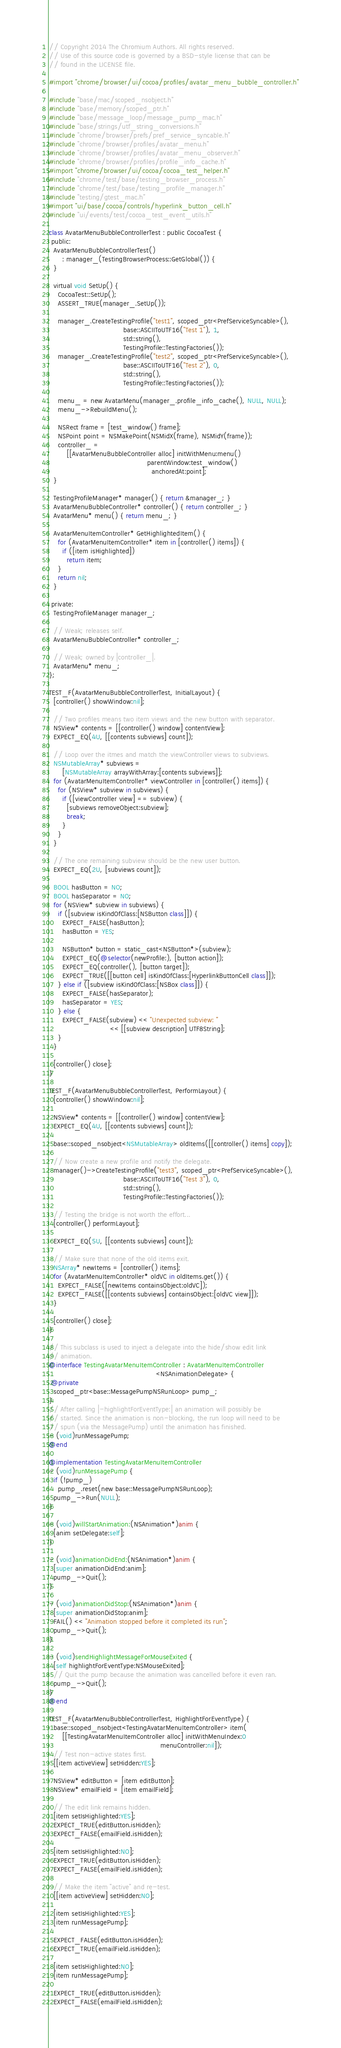<code> <loc_0><loc_0><loc_500><loc_500><_ObjectiveC_>// Copyright 2014 The Chromium Authors. All rights reserved.
// Use of this source code is governed by a BSD-style license that can be
// found in the LICENSE file.

#import "chrome/browser/ui/cocoa/profiles/avatar_menu_bubble_controller.h"

#include "base/mac/scoped_nsobject.h"
#include "base/memory/scoped_ptr.h"
#include "base/message_loop/message_pump_mac.h"
#include "base/strings/utf_string_conversions.h"
#include "chrome/browser/prefs/pref_service_syncable.h"
#include "chrome/browser/profiles/avatar_menu.h"
#include "chrome/browser/profiles/avatar_menu_observer.h"
#include "chrome/browser/profiles/profile_info_cache.h"
#import "chrome/browser/ui/cocoa/cocoa_test_helper.h"
#include "chrome/test/base/testing_browser_process.h"
#include "chrome/test/base/testing_profile_manager.h"
#include "testing/gtest_mac.h"
#import "ui/base/cocoa/controls/hyperlink_button_cell.h"
#include "ui/events/test/cocoa_test_event_utils.h"

class AvatarMenuBubbleControllerTest : public CocoaTest {
 public:
  AvatarMenuBubbleControllerTest()
      : manager_(TestingBrowserProcess::GetGlobal()) {
  }

  virtual void SetUp() {
    CocoaTest::SetUp();
    ASSERT_TRUE(manager_.SetUp());

    manager_.CreateTestingProfile("test1", scoped_ptr<PrefServiceSyncable>(),
                                  base::ASCIIToUTF16("Test 1"), 1,
                                  std::string(),
                                  TestingProfile::TestingFactories());
    manager_.CreateTestingProfile("test2", scoped_ptr<PrefServiceSyncable>(),
                                  base::ASCIIToUTF16("Test 2"), 0,
                                  std::string(),
                                  TestingProfile::TestingFactories());

    menu_ = new AvatarMenu(manager_.profile_info_cache(), NULL, NULL);
    menu_->RebuildMenu();

    NSRect frame = [test_window() frame];
    NSPoint point = NSMakePoint(NSMidX(frame), NSMidY(frame));
    controller_ =
        [[AvatarMenuBubbleController alloc] initWithMenu:menu()
                                             parentWindow:test_window()
                                               anchoredAt:point];
  }

  TestingProfileManager* manager() { return &manager_; }
  AvatarMenuBubbleController* controller() { return controller_; }
  AvatarMenu* menu() { return menu_; }

  AvatarMenuItemController* GetHighlightedItem() {
    for (AvatarMenuItemController* item in [controller() items]) {
      if ([item isHighlighted])
        return item;
    }
    return nil;
  }

 private:
  TestingProfileManager manager_;

  // Weak; releases self.
  AvatarMenuBubbleController* controller_;

  // Weak; owned by |controller_|.
  AvatarMenu* menu_;
};

TEST_F(AvatarMenuBubbleControllerTest, InitialLayout) {
  [controller() showWindow:nil];

  // Two profiles means two item views and the new button with separator.
  NSView* contents = [[controller() window] contentView];
  EXPECT_EQ(4U, [[contents subviews] count]);

  // Loop over the itmes and match the viewController views to subviews.
  NSMutableArray* subviews =
      [NSMutableArray arrayWithArray:[contents subviews]];
  for (AvatarMenuItemController* viewController in [controller() items]) {
    for (NSView* subview in subviews) {
      if ([viewController view] == subview) {
        [subviews removeObject:subview];
        break;
      }
    }
  }

  // The one remaining subview should be the new user button.
  EXPECT_EQ(2U, [subviews count]);

  BOOL hasButton = NO;
  BOOL hasSeparator = NO;
  for (NSView* subview in subviews) {
    if ([subview isKindOfClass:[NSButton class]]) {
      EXPECT_FALSE(hasButton);
      hasButton = YES;

      NSButton* button = static_cast<NSButton*>(subview);
      EXPECT_EQ(@selector(newProfile:), [button action]);
      EXPECT_EQ(controller(), [button target]);
      EXPECT_TRUE([[button cell] isKindOfClass:[HyperlinkButtonCell class]]);
    } else if ([subview isKindOfClass:[NSBox class]]) {
      EXPECT_FALSE(hasSeparator);
      hasSeparator = YES;
    } else {
      EXPECT_FALSE(subview) << "Unexpected subview: "
                            << [[subview description] UTF8String];
    }
  }

  [controller() close];
}

TEST_F(AvatarMenuBubbleControllerTest, PerformLayout) {
  [controller() showWindow:nil];

  NSView* contents = [[controller() window] contentView];
  EXPECT_EQ(4U, [[contents subviews] count]);

  base::scoped_nsobject<NSMutableArray> oldItems([[controller() items] copy]);

  // Now create a new profile and notify the delegate.
  manager()->CreateTestingProfile("test3", scoped_ptr<PrefServiceSyncable>(),
                                  base::ASCIIToUTF16("Test 3"), 0,
                                  std::string(),
                                  TestingProfile::TestingFactories());

  // Testing the bridge is not worth the effort...
  [controller() performLayout];

  EXPECT_EQ(5U, [[contents subviews] count]);

  // Make sure that none of the old items exit.
  NSArray* newItems = [controller() items];
  for (AvatarMenuItemController* oldVC in oldItems.get()) {
    EXPECT_FALSE([newItems containsObject:oldVC]);
    EXPECT_FALSE([[contents subviews] containsObject:[oldVC view]]);
  }

  [controller() close];
}

// This subclass is used to inject a delegate into the hide/show edit link
// animation.
@interface TestingAvatarMenuItemController : AvatarMenuItemController
                                                 <NSAnimationDelegate> {
 @private
  scoped_ptr<base::MessagePumpNSRunLoop> pump_;
}
// After calling |-highlightForEventType:| an animation will possibly be
// started. Since the animation is non-blocking, the run loop will need to be
// spun (via the MessagePump) until the animation has finished.
- (void)runMessagePump;
@end

@implementation TestingAvatarMenuItemController
- (void)runMessagePump {
  if (!pump_)
    pump_.reset(new base::MessagePumpNSRunLoop);
  pump_->Run(NULL);
}

- (void)willStartAnimation:(NSAnimation*)anim {
  [anim setDelegate:self];
}

- (void)animationDidEnd:(NSAnimation*)anim {
  [super animationDidEnd:anim];
  pump_->Quit();
}

- (void)animationDidStop:(NSAnimation*)anim {
  [super animationDidStop:anim];
  FAIL() << "Animation stopped before it completed its run";
  pump_->Quit();
}

- (void)sendHighlightMessageForMouseExited {
  [self highlightForEventType:NSMouseExited];
  // Quit the pump because the animation was cancelled before it even ran.
  pump_->Quit();
}
@end

TEST_F(AvatarMenuBubbleControllerTest, HighlightForEventType) {
  base::scoped_nsobject<TestingAvatarMenuItemController> item(
      [[TestingAvatarMenuItemController alloc] initWithMenuIndex:0
                                                   menuController:nil]);
  // Test non-active states first.
  [[item activeView] setHidden:YES];

  NSView* editButton = [item editButton];
  NSView* emailField = [item emailField];

  // The edit link remains hidden.
  [item setIsHighlighted:YES];
  EXPECT_TRUE(editButton.isHidden);
  EXPECT_FALSE(emailField.isHidden);

  [item setIsHighlighted:NO];
  EXPECT_TRUE(editButton.isHidden);
  EXPECT_FALSE(emailField.isHidden);

  // Make the item "active" and re-test.
  [[item activeView] setHidden:NO];

  [item setIsHighlighted:YES];
  [item runMessagePump];

  EXPECT_FALSE(editButton.isHidden);
  EXPECT_TRUE(emailField.isHidden);

  [item setIsHighlighted:NO];
  [item runMessagePump];

  EXPECT_TRUE(editButton.isHidden);
  EXPECT_FALSE(emailField.isHidden);
</code> 